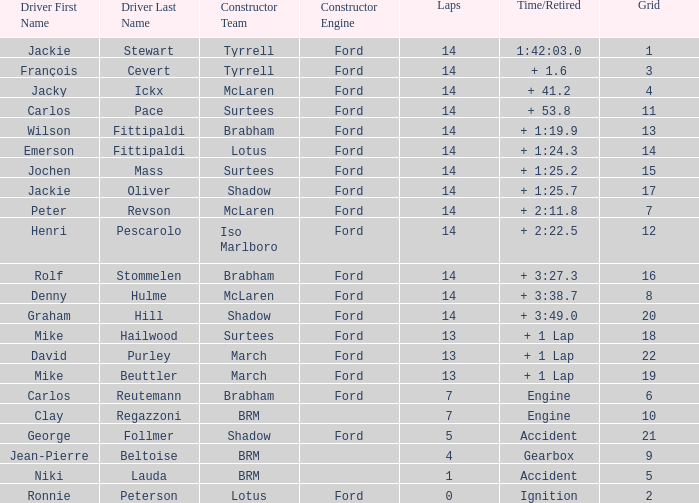What is the low lap total for a grid larger than 16 and has a Time/Retired of + 3:27.3? None. 